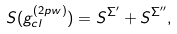<formula> <loc_0><loc_0><loc_500><loc_500>S ( g _ { c l } ^ { ( 2 p w ) } ) = S ^ { \Sigma ^ { \prime } } + S ^ { \Sigma ^ { \prime \prime } } ,</formula> 